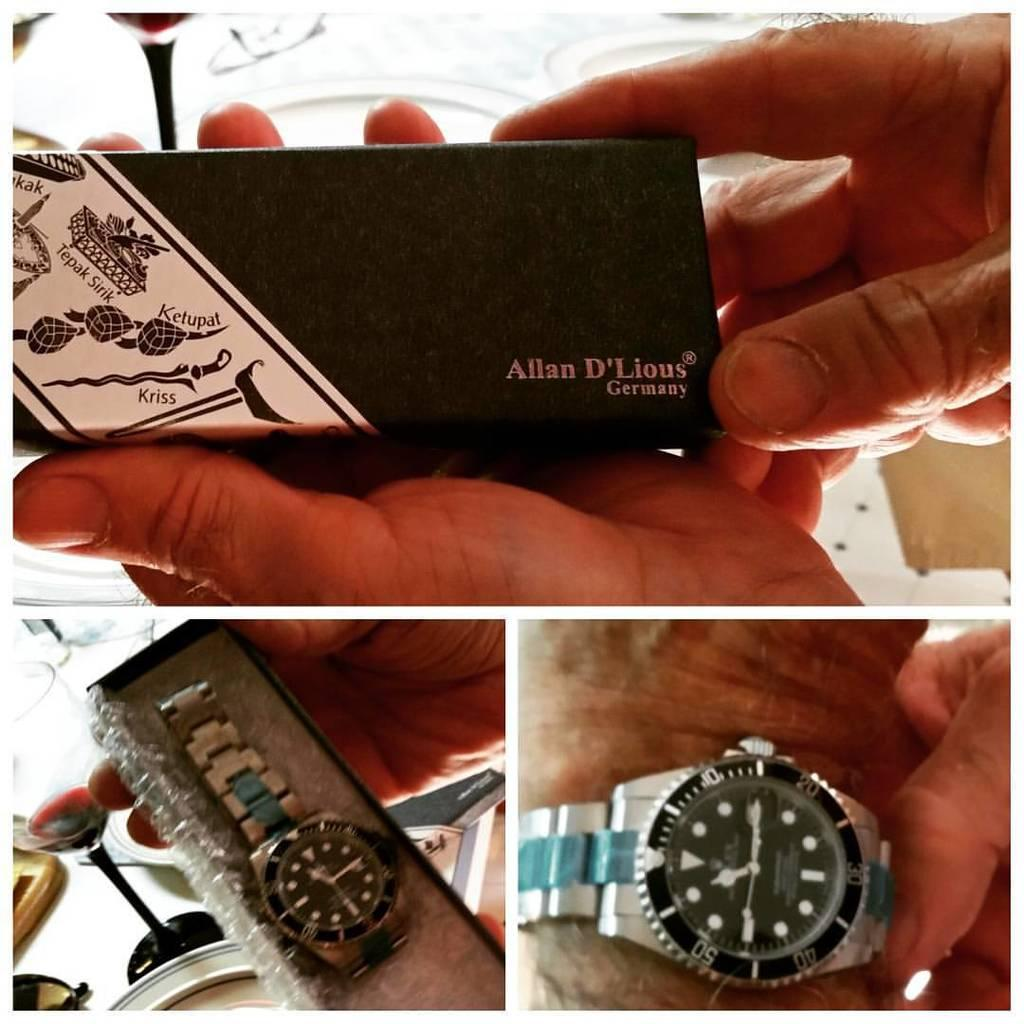<image>
Give a short and clear explanation of the subsequent image. A gift box that has a watch in it comes from Germany. 